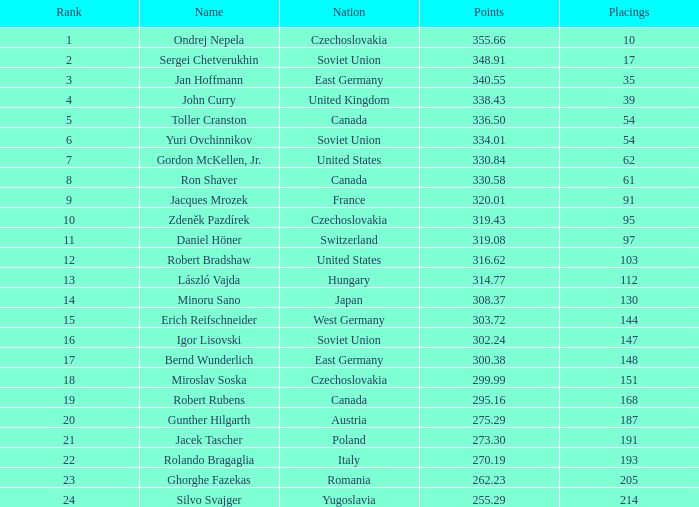72? None. 